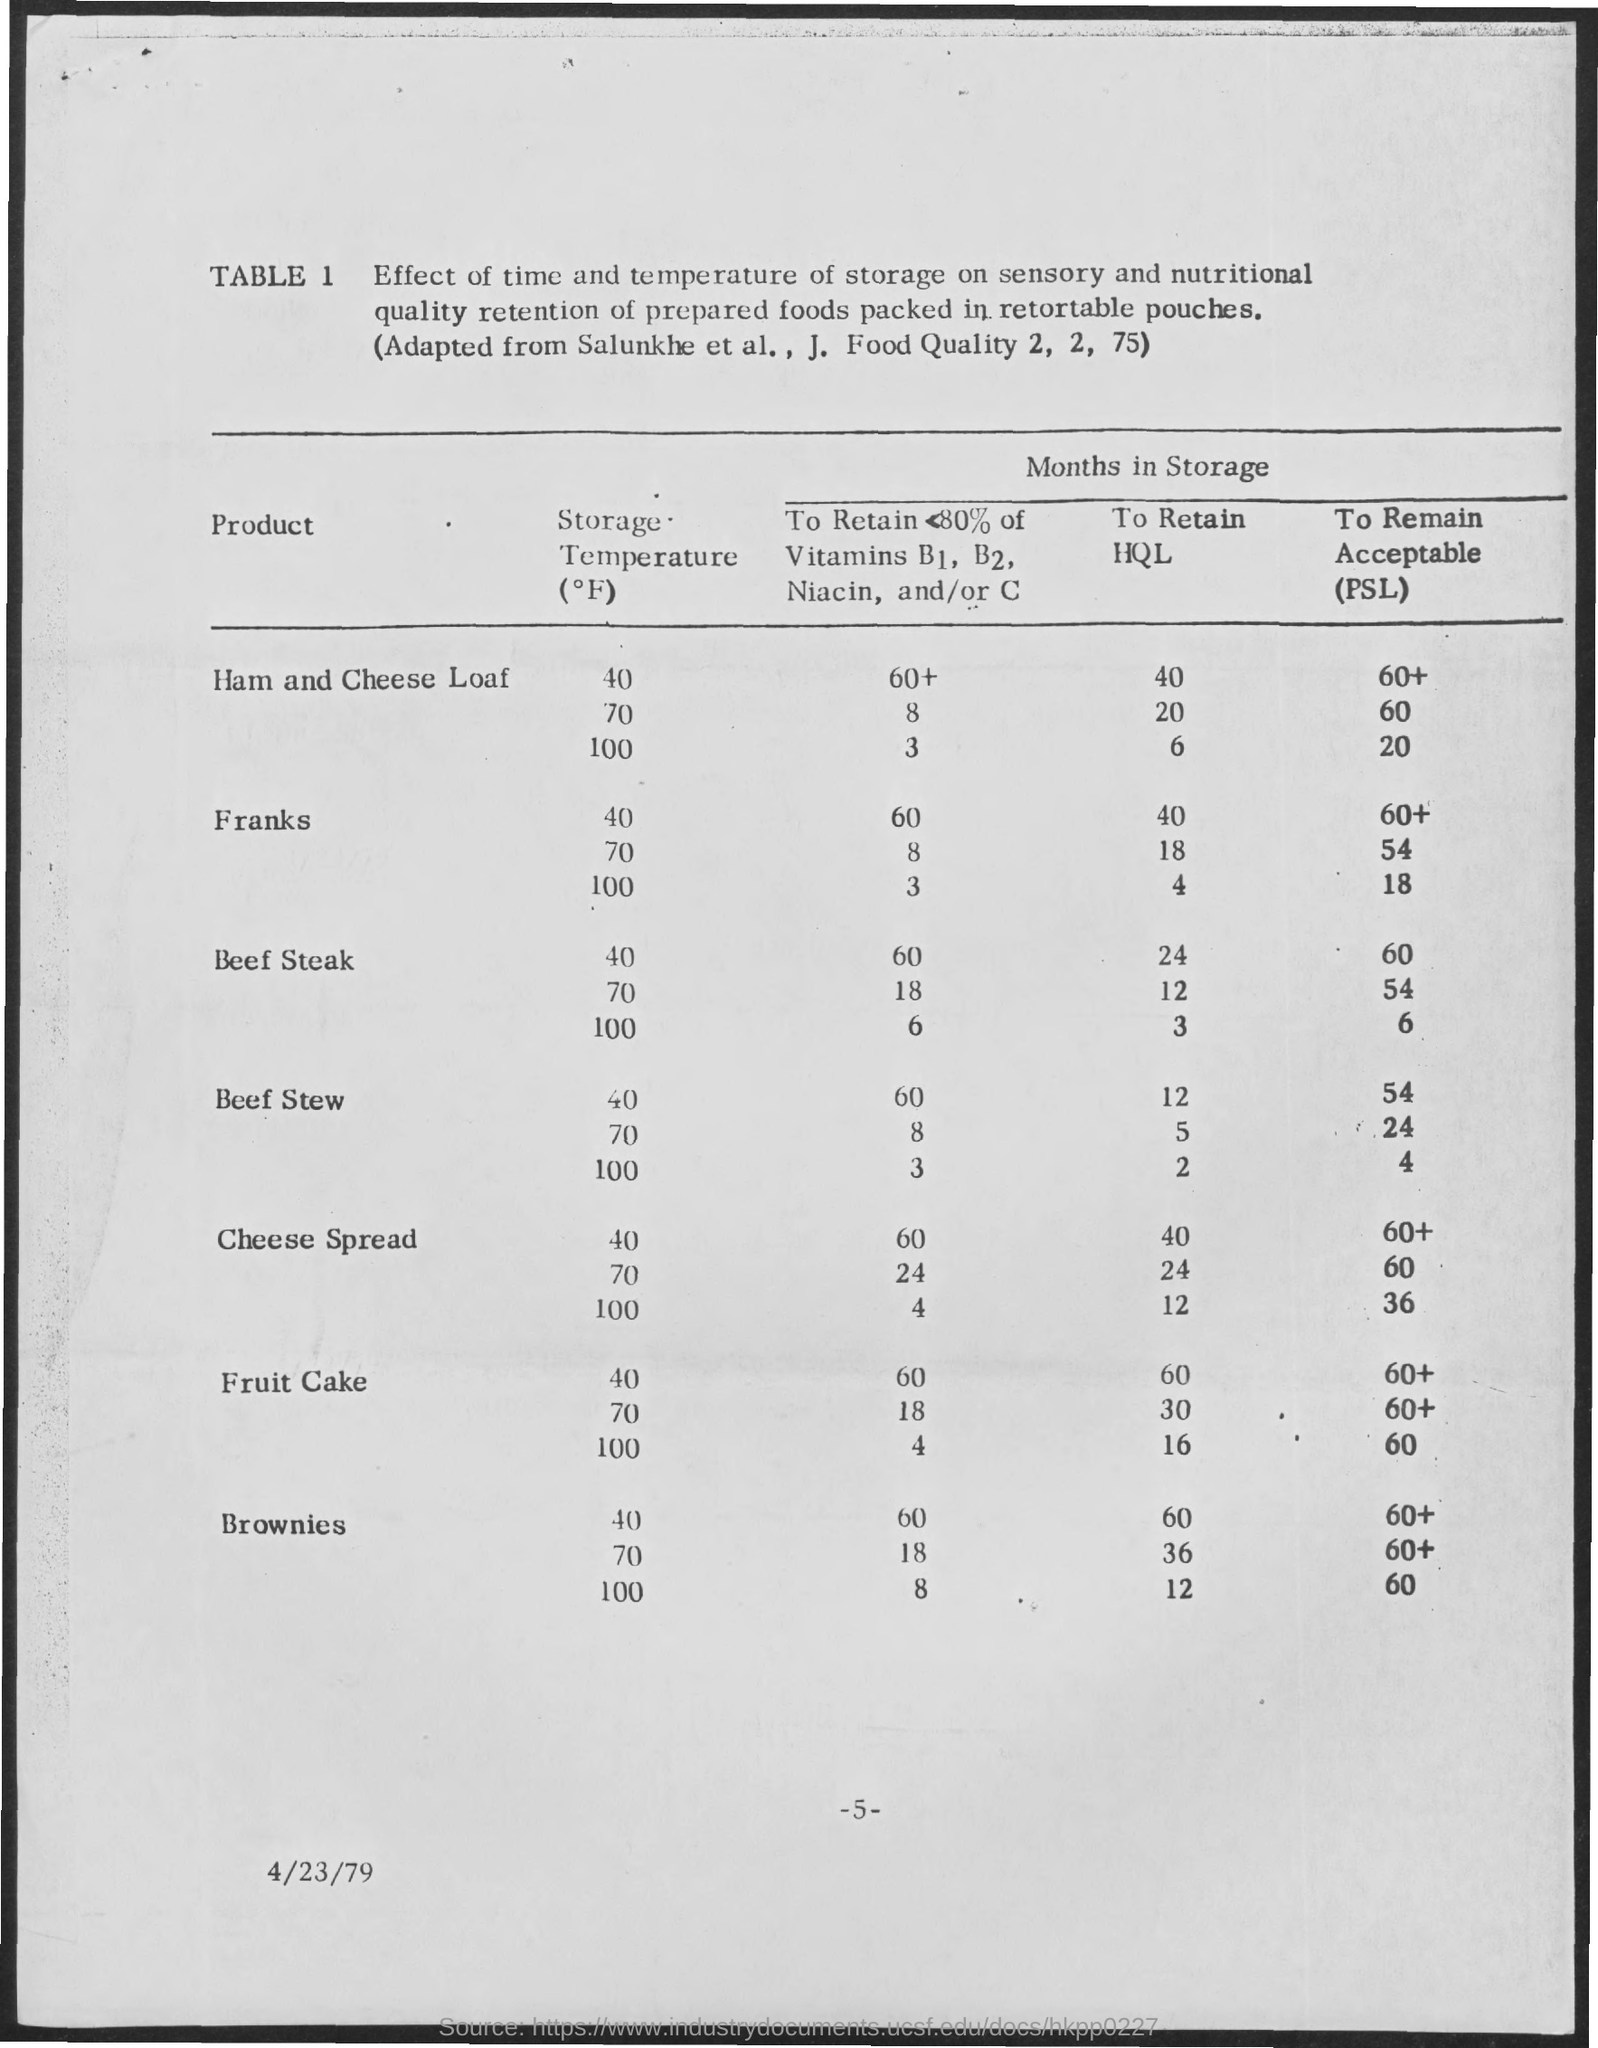What is the date on the document?
Offer a very short reply. 4/23/79. 